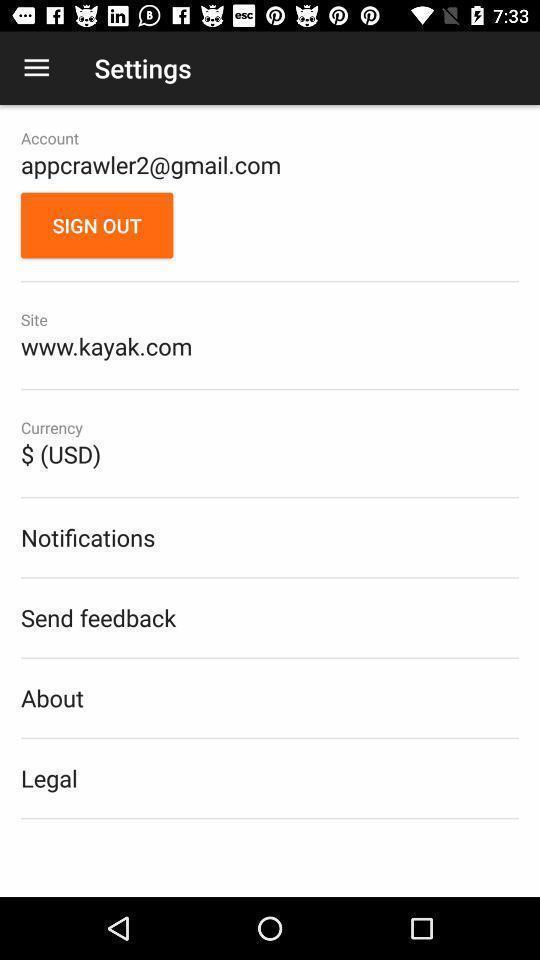What details can you identify in this image? Setting page displaying a profile with various information. 